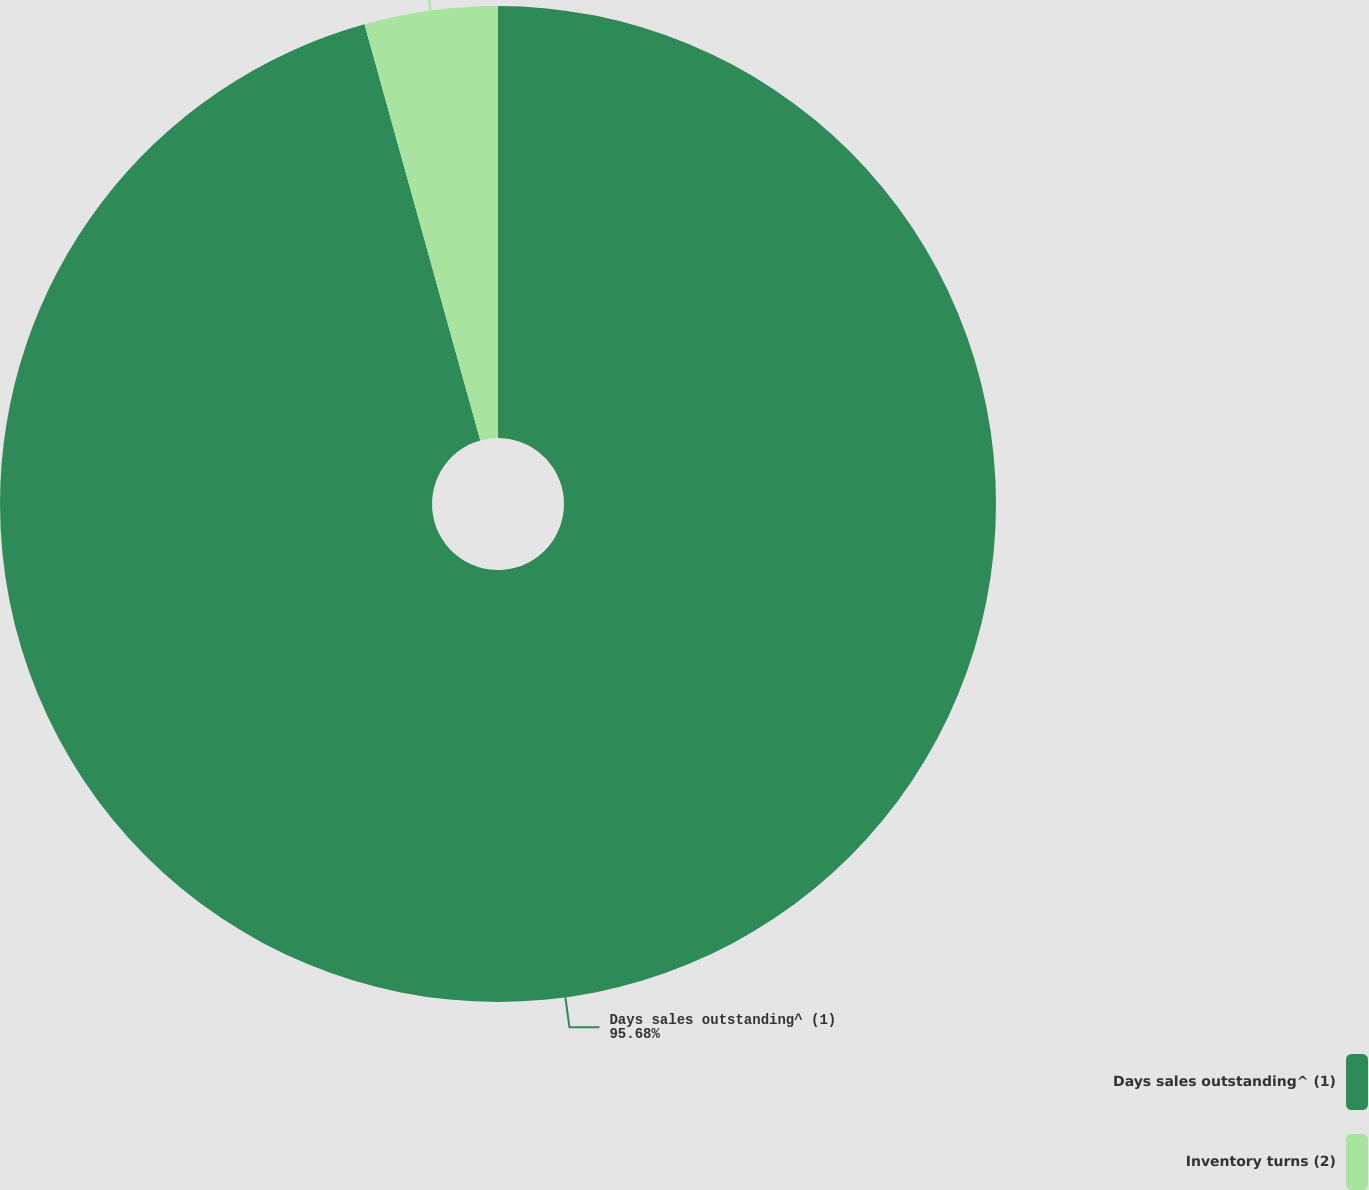Convert chart. <chart><loc_0><loc_0><loc_500><loc_500><pie_chart><fcel>Days sales outstanding^ (1)<fcel>Inventory turns (2)<nl><fcel>95.68%<fcel>4.32%<nl></chart> 